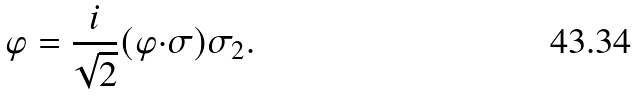Convert formula to latex. <formula><loc_0><loc_0><loc_500><loc_500>\varphi = \frac { i } { \sqrt { 2 } } ( { \varphi } { \cdot } { \sigma } ) \sigma _ { 2 } .</formula> 